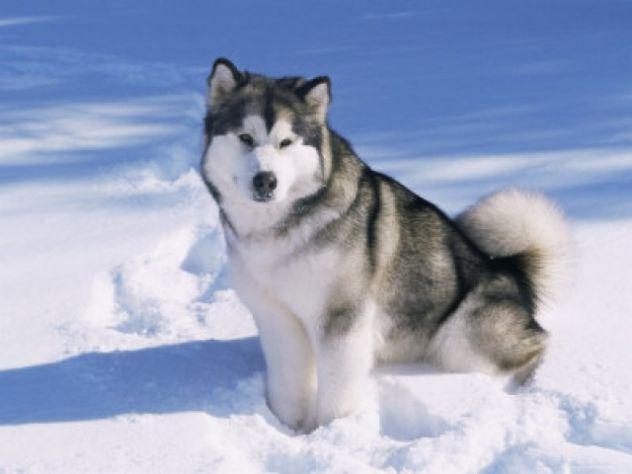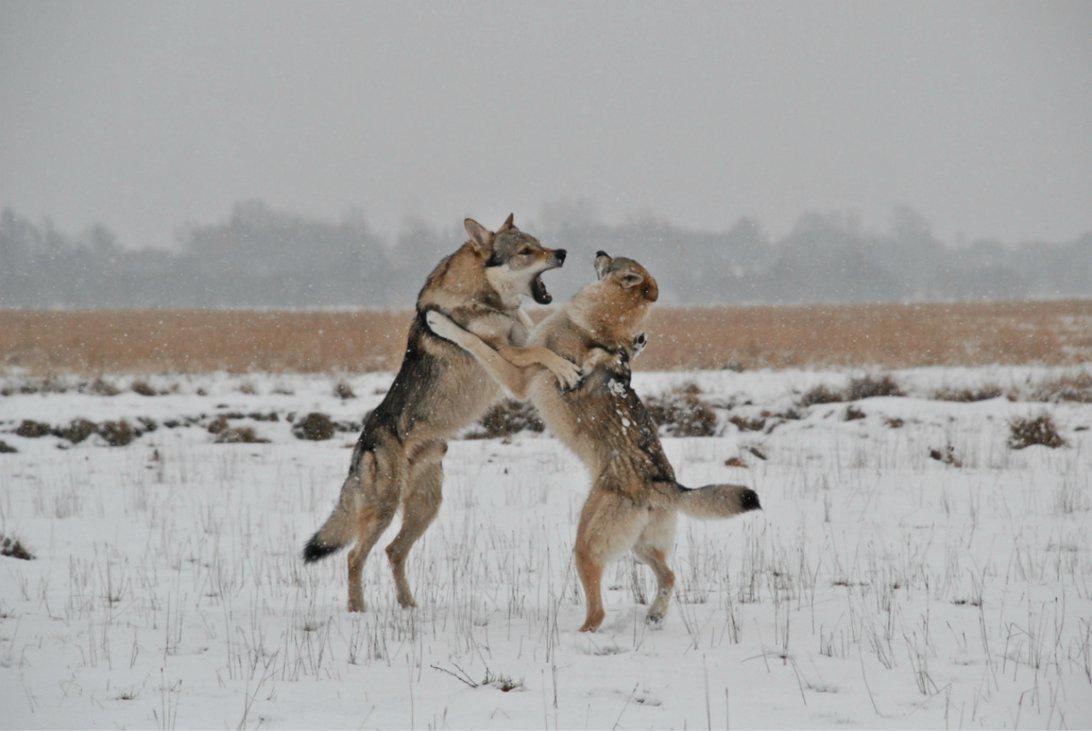The first image is the image on the left, the second image is the image on the right. Analyze the images presented: Is the assertion "The left image contains exactly one dog." valid? Answer yes or no. Yes. The first image is the image on the left, the second image is the image on the right. Given the left and right images, does the statement "One of the images shows a body of water in the background." hold true? Answer yes or no. No. 